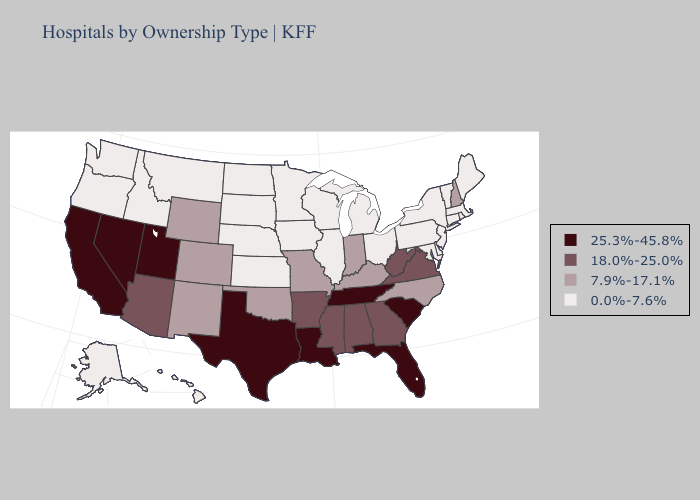Which states have the lowest value in the West?
Keep it brief. Alaska, Hawaii, Idaho, Montana, Oregon, Washington. Name the states that have a value in the range 25.3%-45.8%?
Short answer required. California, Florida, Louisiana, Nevada, South Carolina, Tennessee, Texas, Utah. What is the highest value in states that border Mississippi?
Give a very brief answer. 25.3%-45.8%. Among the states that border Nevada , does California have the lowest value?
Short answer required. No. What is the value of Maine?
Concise answer only. 0.0%-7.6%. Among the states that border Arkansas , does Tennessee have the highest value?
Write a very short answer. Yes. What is the lowest value in states that border Washington?
Short answer required. 0.0%-7.6%. What is the value of South Carolina?
Quick response, please. 25.3%-45.8%. Name the states that have a value in the range 7.9%-17.1%?
Short answer required. Colorado, Indiana, Kentucky, Missouri, New Hampshire, New Mexico, North Carolina, Oklahoma, Wyoming. Does the first symbol in the legend represent the smallest category?
Write a very short answer. No. Name the states that have a value in the range 7.9%-17.1%?
Concise answer only. Colorado, Indiana, Kentucky, Missouri, New Hampshire, New Mexico, North Carolina, Oklahoma, Wyoming. What is the value of Maryland?
Concise answer only. 0.0%-7.6%. Does South Carolina have the lowest value in the South?
Quick response, please. No. What is the lowest value in the Northeast?
Short answer required. 0.0%-7.6%. 